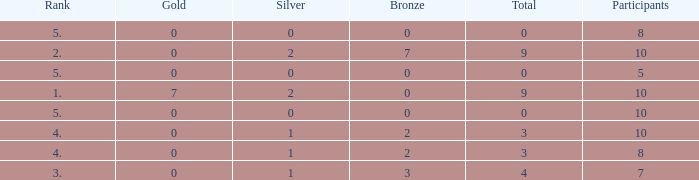What's the total Rank that has a Gold that's smaller than 0? None. 